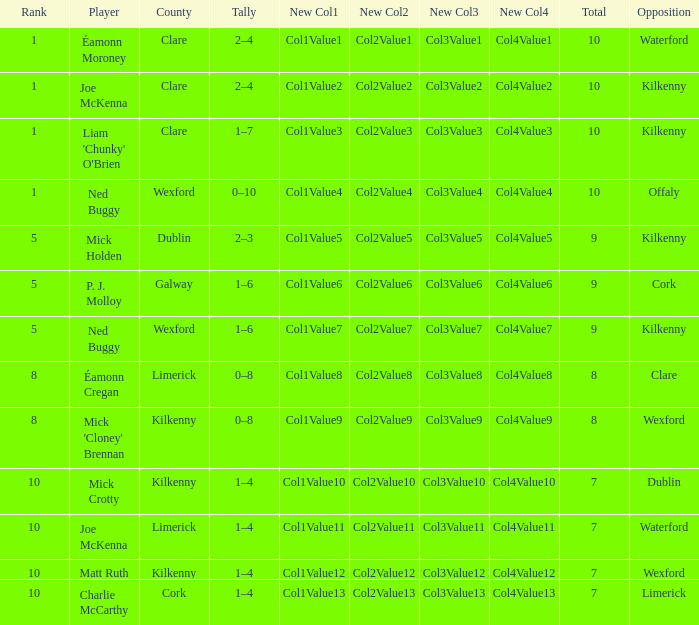What is galway county's total? 9.0. 